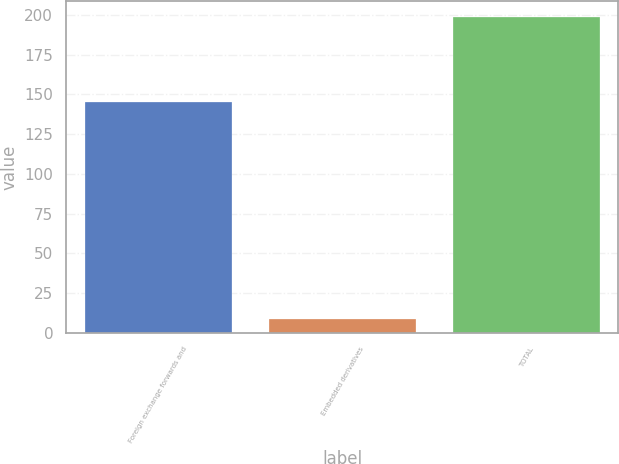Convert chart. <chart><loc_0><loc_0><loc_500><loc_500><bar_chart><fcel>Foreign exchange forwards and<fcel>Embedded derivatives<fcel>TOTAL<nl><fcel>145<fcel>9<fcel>199<nl></chart> 